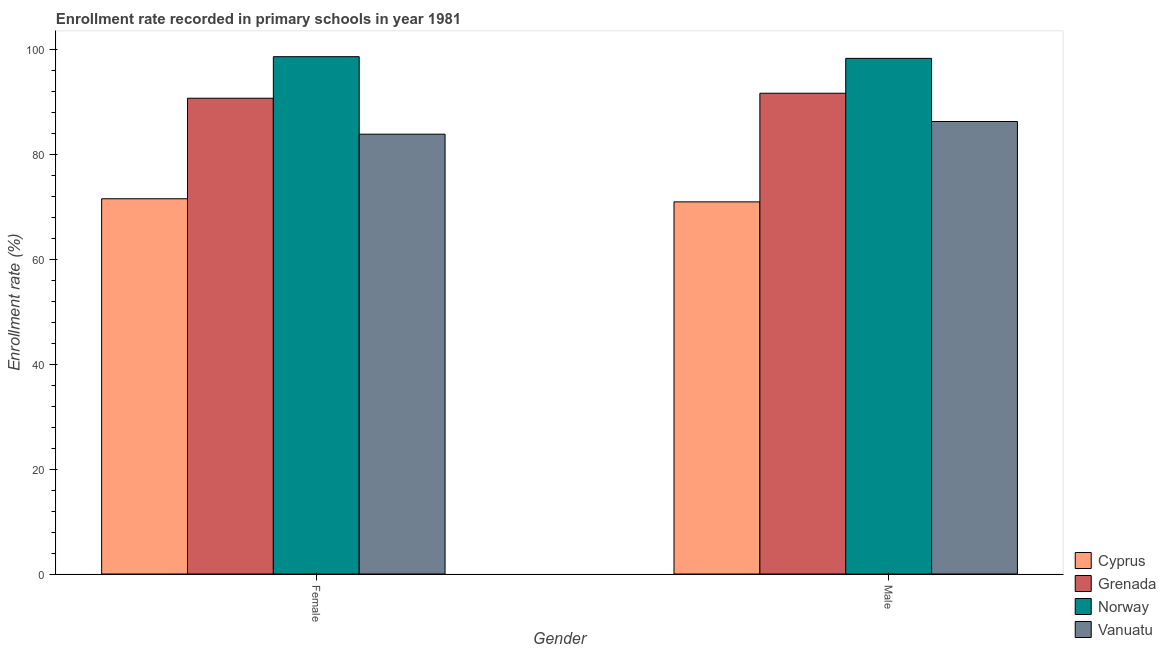How many different coloured bars are there?
Make the answer very short. 4. Are the number of bars on each tick of the X-axis equal?
Give a very brief answer. Yes. How many bars are there on the 2nd tick from the left?
Your answer should be compact. 4. How many bars are there on the 1st tick from the right?
Ensure brevity in your answer.  4. What is the label of the 2nd group of bars from the left?
Keep it short and to the point. Male. What is the enrollment rate of male students in Vanuatu?
Your response must be concise. 86.24. Across all countries, what is the maximum enrollment rate of male students?
Ensure brevity in your answer.  98.27. Across all countries, what is the minimum enrollment rate of male students?
Offer a terse response. 70.92. In which country was the enrollment rate of male students maximum?
Provide a succinct answer. Norway. In which country was the enrollment rate of male students minimum?
Give a very brief answer. Cyprus. What is the total enrollment rate of female students in the graph?
Keep it short and to the point. 344.61. What is the difference between the enrollment rate of male students in Cyprus and that in Grenada?
Provide a short and direct response. -20.7. What is the difference between the enrollment rate of male students in Grenada and the enrollment rate of female students in Norway?
Your response must be concise. -6.97. What is the average enrollment rate of male students per country?
Ensure brevity in your answer.  86.77. What is the difference between the enrollment rate of male students and enrollment rate of female students in Norway?
Your answer should be very brief. -0.32. In how many countries, is the enrollment rate of male students greater than 92 %?
Provide a short and direct response. 1. What is the ratio of the enrollment rate of male students in Grenada to that in Vanuatu?
Give a very brief answer. 1.06. In how many countries, is the enrollment rate of female students greater than the average enrollment rate of female students taken over all countries?
Offer a very short reply. 2. What does the 4th bar from the left in Male represents?
Provide a succinct answer. Vanuatu. What does the 1st bar from the right in Male represents?
Your response must be concise. Vanuatu. How many bars are there?
Provide a succinct answer. 8. Are all the bars in the graph horizontal?
Provide a succinct answer. No. How many countries are there in the graph?
Give a very brief answer. 4. What is the difference between two consecutive major ticks on the Y-axis?
Keep it short and to the point. 20. Does the graph contain any zero values?
Your response must be concise. No. How many legend labels are there?
Offer a very short reply. 4. What is the title of the graph?
Offer a terse response. Enrollment rate recorded in primary schools in year 1981. Does "Latin America(developing only)" appear as one of the legend labels in the graph?
Offer a very short reply. No. What is the label or title of the Y-axis?
Your answer should be very brief. Enrollment rate (%). What is the Enrollment rate (%) in Cyprus in Female?
Your response must be concise. 71.52. What is the Enrollment rate (%) in Grenada in Female?
Keep it short and to the point. 90.68. What is the Enrollment rate (%) of Norway in Female?
Make the answer very short. 98.59. What is the Enrollment rate (%) of Vanuatu in Female?
Offer a terse response. 83.82. What is the Enrollment rate (%) in Cyprus in Male?
Keep it short and to the point. 70.92. What is the Enrollment rate (%) in Grenada in Male?
Your response must be concise. 91.63. What is the Enrollment rate (%) of Norway in Male?
Give a very brief answer. 98.27. What is the Enrollment rate (%) in Vanuatu in Male?
Give a very brief answer. 86.24. Across all Gender, what is the maximum Enrollment rate (%) of Cyprus?
Your response must be concise. 71.52. Across all Gender, what is the maximum Enrollment rate (%) in Grenada?
Offer a terse response. 91.63. Across all Gender, what is the maximum Enrollment rate (%) in Norway?
Make the answer very short. 98.59. Across all Gender, what is the maximum Enrollment rate (%) in Vanuatu?
Offer a terse response. 86.24. Across all Gender, what is the minimum Enrollment rate (%) of Cyprus?
Provide a short and direct response. 70.92. Across all Gender, what is the minimum Enrollment rate (%) in Grenada?
Offer a terse response. 90.68. Across all Gender, what is the minimum Enrollment rate (%) in Norway?
Your response must be concise. 98.27. Across all Gender, what is the minimum Enrollment rate (%) of Vanuatu?
Ensure brevity in your answer.  83.82. What is the total Enrollment rate (%) of Cyprus in the graph?
Your answer should be very brief. 142.44. What is the total Enrollment rate (%) in Grenada in the graph?
Offer a very short reply. 182.3. What is the total Enrollment rate (%) in Norway in the graph?
Your answer should be compact. 196.86. What is the total Enrollment rate (%) of Vanuatu in the graph?
Provide a short and direct response. 170.06. What is the difference between the Enrollment rate (%) of Cyprus in Female and that in Male?
Make the answer very short. 0.59. What is the difference between the Enrollment rate (%) in Grenada in Female and that in Male?
Offer a terse response. -0.95. What is the difference between the Enrollment rate (%) of Norway in Female and that in Male?
Ensure brevity in your answer.  0.32. What is the difference between the Enrollment rate (%) in Vanuatu in Female and that in Male?
Provide a succinct answer. -2.42. What is the difference between the Enrollment rate (%) in Cyprus in Female and the Enrollment rate (%) in Grenada in Male?
Provide a succinct answer. -20.11. What is the difference between the Enrollment rate (%) of Cyprus in Female and the Enrollment rate (%) of Norway in Male?
Offer a terse response. -26.75. What is the difference between the Enrollment rate (%) in Cyprus in Female and the Enrollment rate (%) in Vanuatu in Male?
Provide a succinct answer. -14.72. What is the difference between the Enrollment rate (%) in Grenada in Female and the Enrollment rate (%) in Norway in Male?
Your answer should be very brief. -7.59. What is the difference between the Enrollment rate (%) in Grenada in Female and the Enrollment rate (%) in Vanuatu in Male?
Your answer should be compact. 4.44. What is the difference between the Enrollment rate (%) of Norway in Female and the Enrollment rate (%) of Vanuatu in Male?
Your answer should be compact. 12.35. What is the average Enrollment rate (%) in Cyprus per Gender?
Keep it short and to the point. 71.22. What is the average Enrollment rate (%) in Grenada per Gender?
Your response must be concise. 91.15. What is the average Enrollment rate (%) of Norway per Gender?
Your response must be concise. 98.43. What is the average Enrollment rate (%) in Vanuatu per Gender?
Offer a terse response. 85.03. What is the difference between the Enrollment rate (%) in Cyprus and Enrollment rate (%) in Grenada in Female?
Keep it short and to the point. -19.16. What is the difference between the Enrollment rate (%) of Cyprus and Enrollment rate (%) of Norway in Female?
Your response must be concise. -27.08. What is the difference between the Enrollment rate (%) in Cyprus and Enrollment rate (%) in Vanuatu in Female?
Give a very brief answer. -12.3. What is the difference between the Enrollment rate (%) in Grenada and Enrollment rate (%) in Norway in Female?
Your answer should be compact. -7.92. What is the difference between the Enrollment rate (%) of Grenada and Enrollment rate (%) of Vanuatu in Female?
Keep it short and to the point. 6.86. What is the difference between the Enrollment rate (%) of Norway and Enrollment rate (%) of Vanuatu in Female?
Your answer should be very brief. 14.77. What is the difference between the Enrollment rate (%) in Cyprus and Enrollment rate (%) in Grenada in Male?
Provide a short and direct response. -20.7. What is the difference between the Enrollment rate (%) of Cyprus and Enrollment rate (%) of Norway in Male?
Give a very brief answer. -27.35. What is the difference between the Enrollment rate (%) of Cyprus and Enrollment rate (%) of Vanuatu in Male?
Provide a succinct answer. -15.31. What is the difference between the Enrollment rate (%) of Grenada and Enrollment rate (%) of Norway in Male?
Offer a terse response. -6.64. What is the difference between the Enrollment rate (%) in Grenada and Enrollment rate (%) in Vanuatu in Male?
Make the answer very short. 5.39. What is the difference between the Enrollment rate (%) in Norway and Enrollment rate (%) in Vanuatu in Male?
Offer a terse response. 12.03. What is the ratio of the Enrollment rate (%) in Cyprus in Female to that in Male?
Ensure brevity in your answer.  1.01. What is the ratio of the Enrollment rate (%) in Grenada in Female to that in Male?
Your answer should be very brief. 0.99. What is the ratio of the Enrollment rate (%) of Norway in Female to that in Male?
Offer a terse response. 1. What is the difference between the highest and the second highest Enrollment rate (%) in Cyprus?
Make the answer very short. 0.59. What is the difference between the highest and the second highest Enrollment rate (%) of Grenada?
Give a very brief answer. 0.95. What is the difference between the highest and the second highest Enrollment rate (%) in Norway?
Ensure brevity in your answer.  0.32. What is the difference between the highest and the second highest Enrollment rate (%) in Vanuatu?
Provide a short and direct response. 2.42. What is the difference between the highest and the lowest Enrollment rate (%) of Cyprus?
Ensure brevity in your answer.  0.59. What is the difference between the highest and the lowest Enrollment rate (%) of Grenada?
Provide a succinct answer. 0.95. What is the difference between the highest and the lowest Enrollment rate (%) in Norway?
Provide a short and direct response. 0.32. What is the difference between the highest and the lowest Enrollment rate (%) in Vanuatu?
Ensure brevity in your answer.  2.42. 